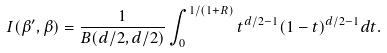Convert formula to latex. <formula><loc_0><loc_0><loc_500><loc_500>I ( \beta ^ { \prime } , \beta ) = \frac { 1 } { B ( d / 2 , d / 2 ) } \int _ { 0 } ^ { 1 / ( 1 + R ) } t ^ { d / 2 - 1 } ( 1 - t ) ^ { d / 2 - 1 } d t .</formula> 